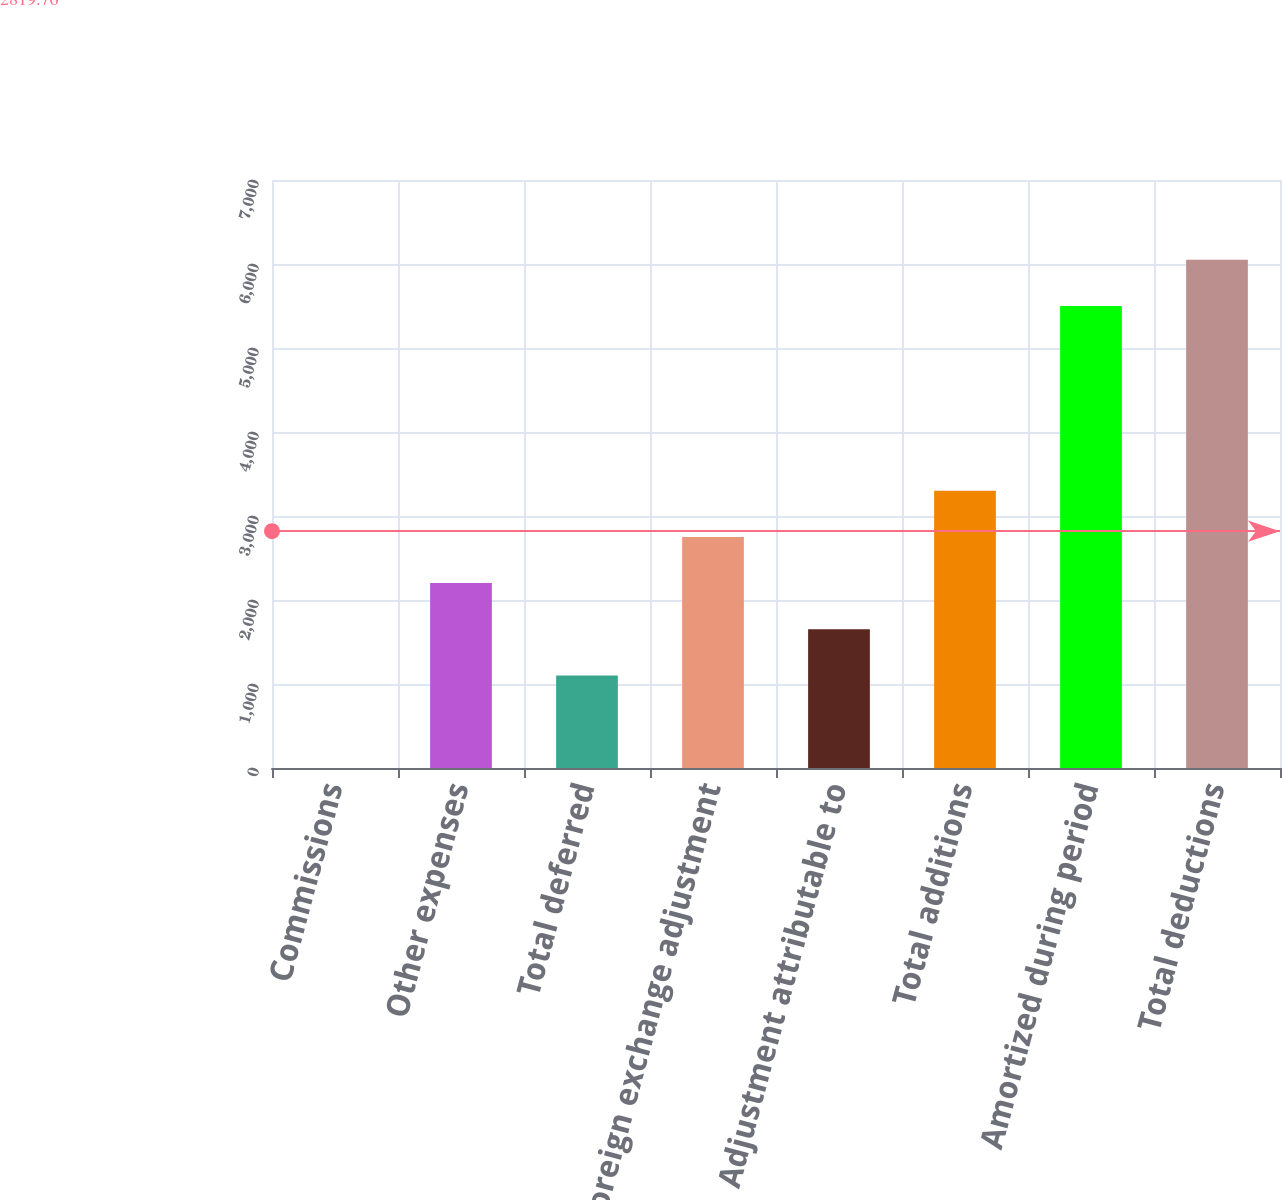<chart> <loc_0><loc_0><loc_500><loc_500><bar_chart><fcel>Commissions<fcel>Other expenses<fcel>Total deferred<fcel>Foreign exchange adjustment<fcel>Adjustment attributable to<fcel>Total additions<fcel>Amortized during period<fcel>Total deductions<nl><fcel>1.01<fcel>2201.01<fcel>1101.01<fcel>2751.01<fcel>1651.01<fcel>3301.01<fcel>5501<fcel>6051<nl></chart> 